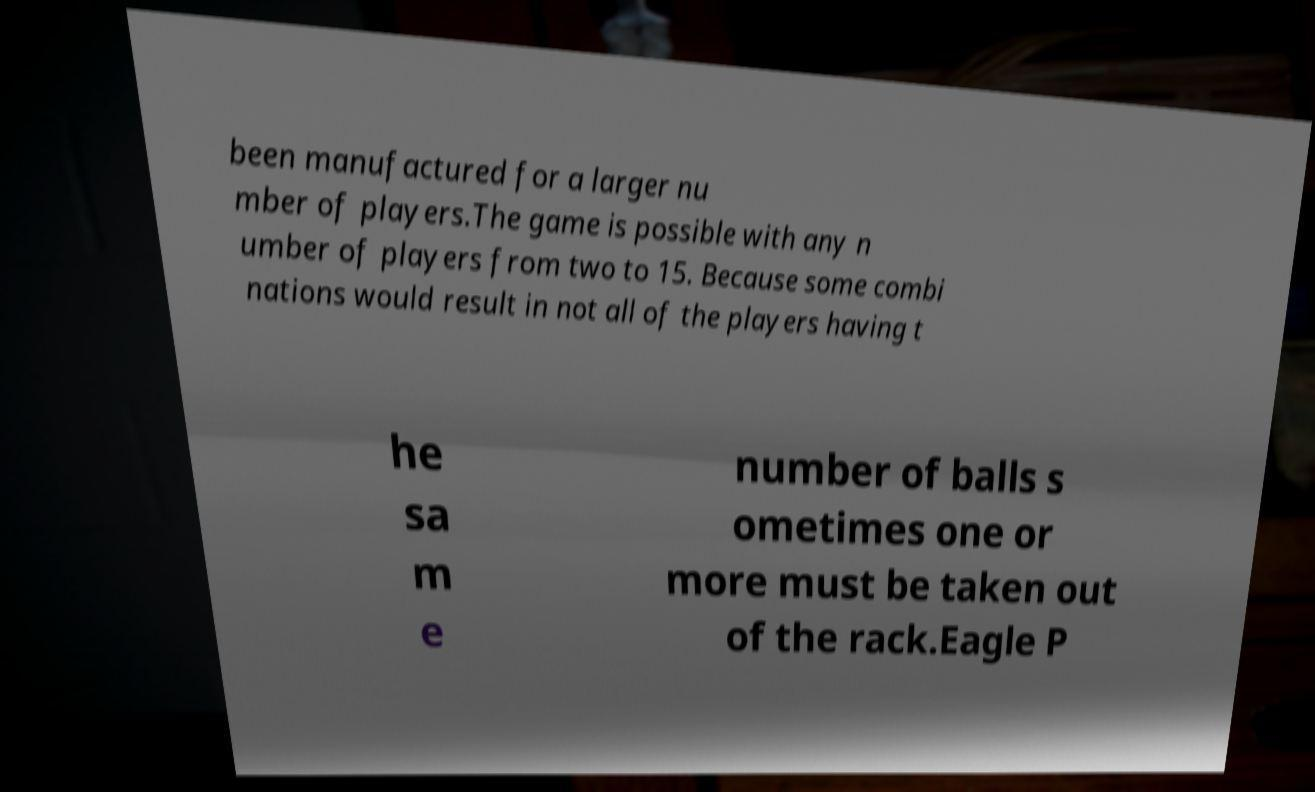Can you accurately transcribe the text from the provided image for me? been manufactured for a larger nu mber of players.The game is possible with any n umber of players from two to 15. Because some combi nations would result in not all of the players having t he sa m e number of balls s ometimes one or more must be taken out of the rack.Eagle P 